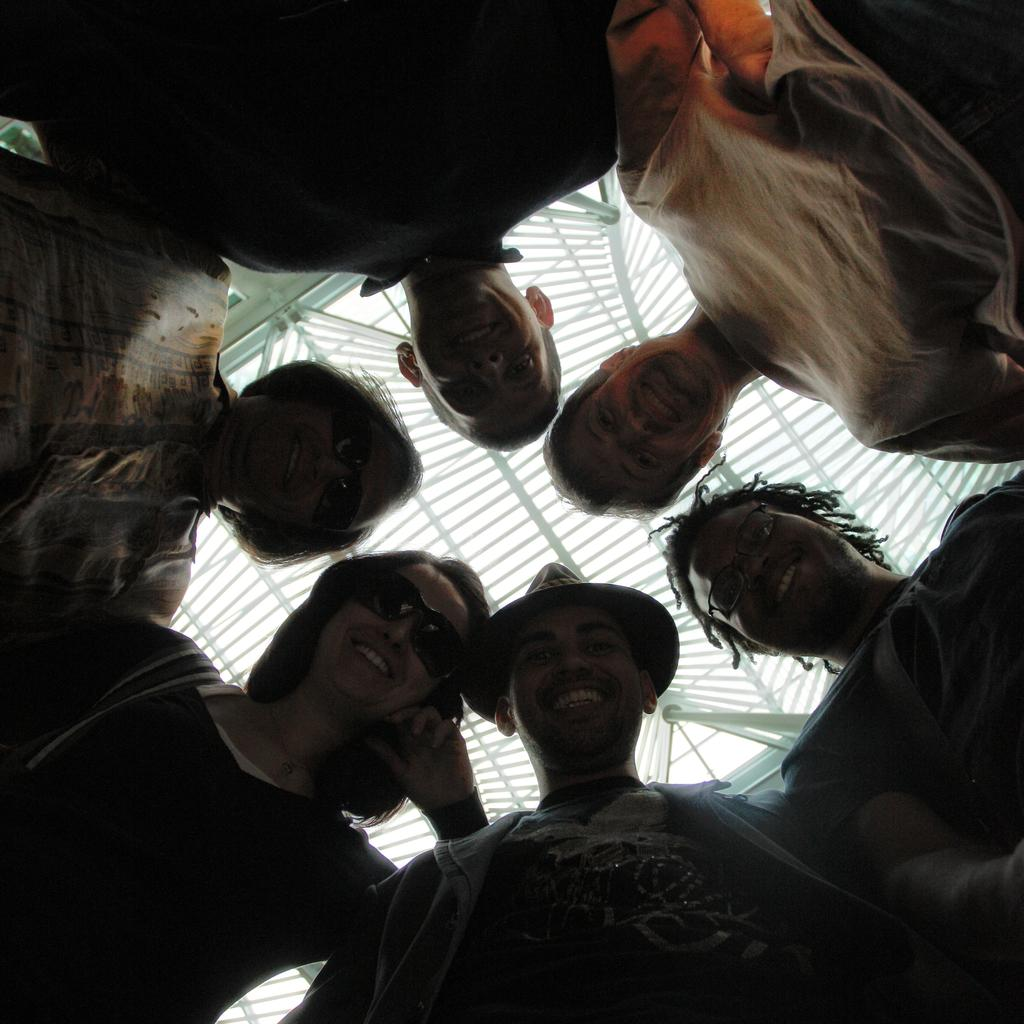What can be observed about the people in the image? There are people standing in the image. What protective gear are two of the women wearing? Two women in the image are wearing goggles. What part of the room can be seen at the top of the image? There is a ceiling visible at the top of the image. What type of headwear is a man in the image wearing? A man in the image is wearing a cap. What type of pain is the queen experiencing in the image? There is no queen present in the image, and therefore no indication of any pain being experienced. 